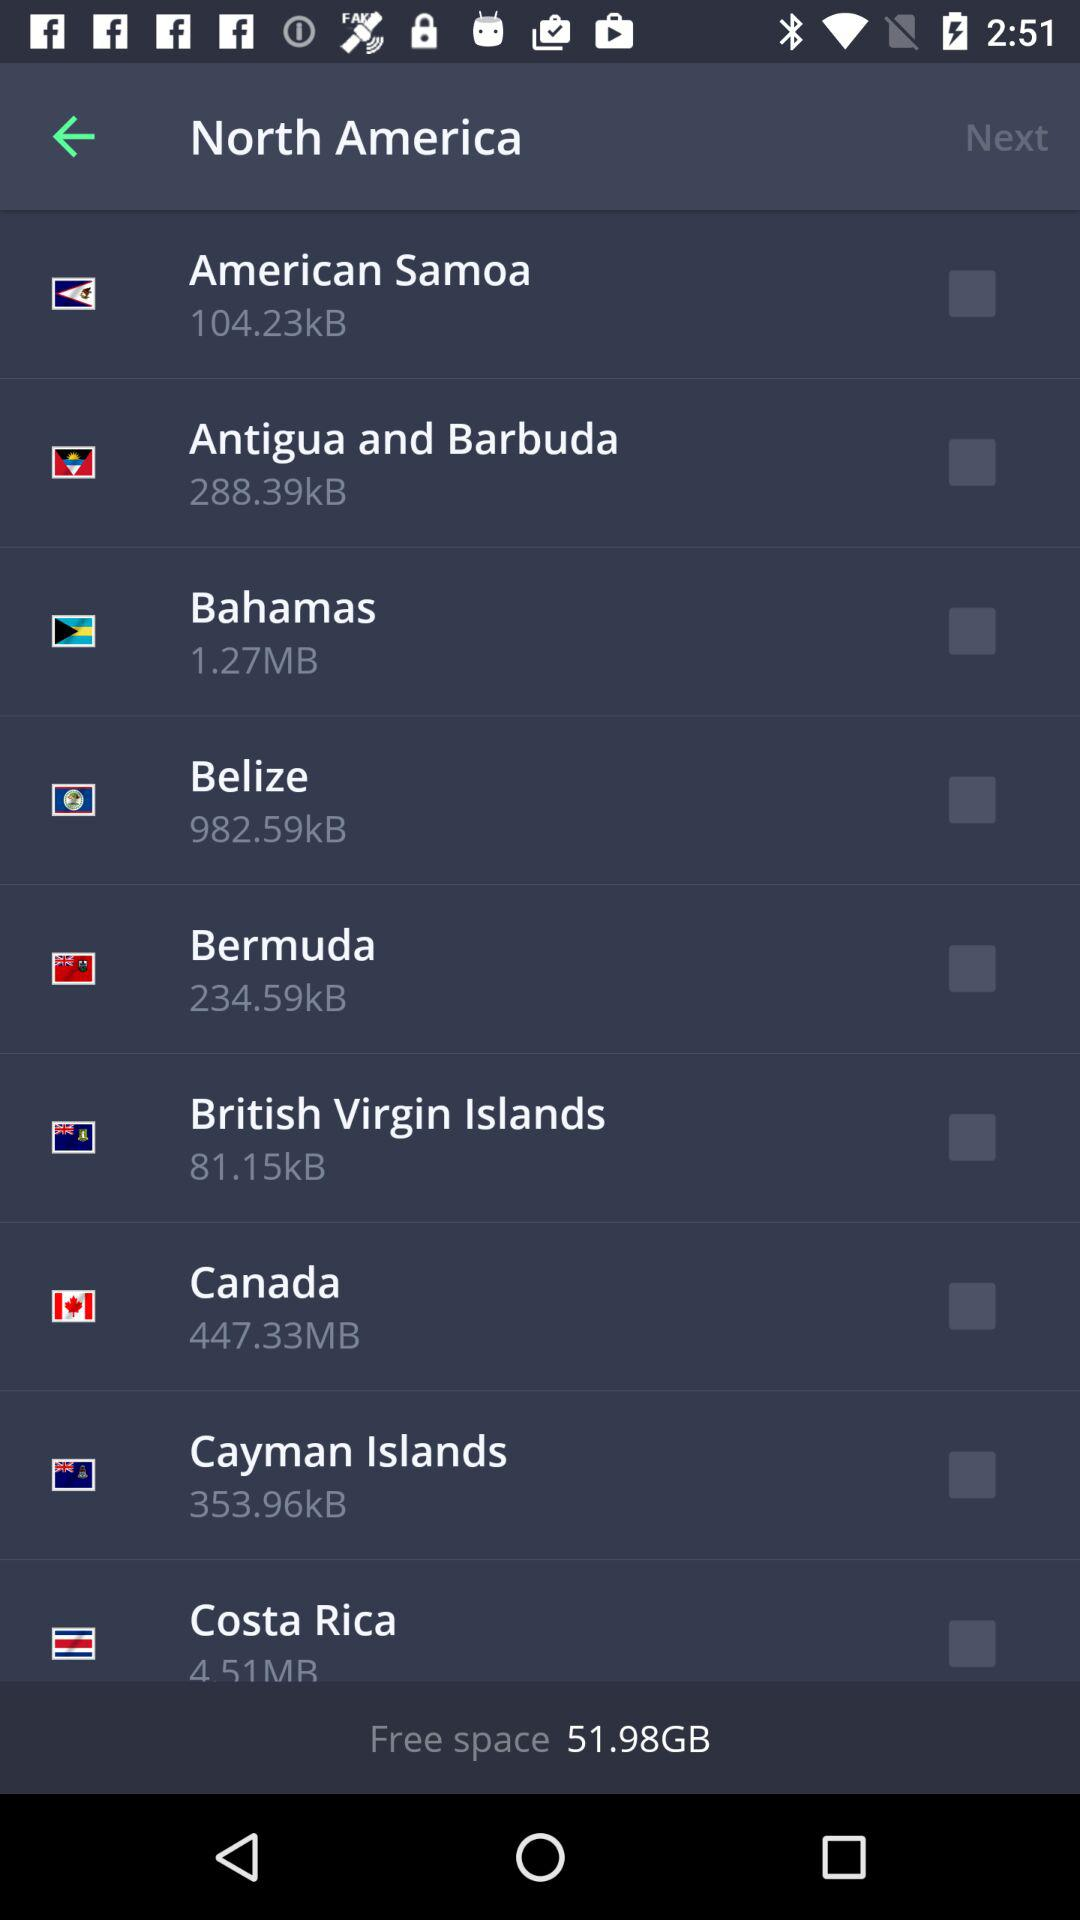What is the size of "Bermuda"? The size of "Bermuda" is 234.59kB. 